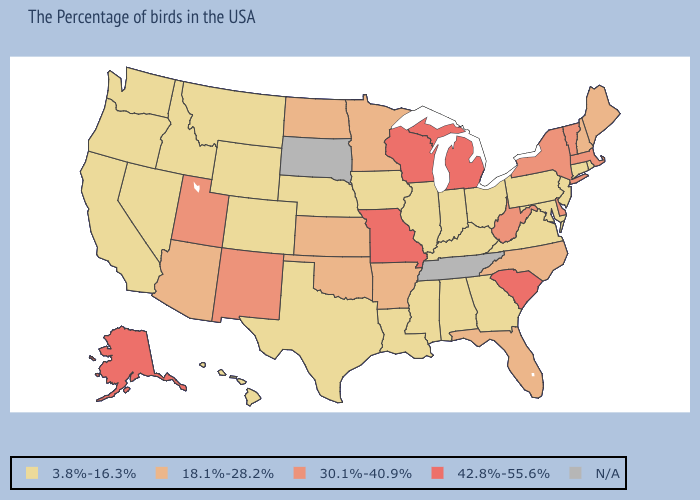What is the highest value in states that border Oregon?
Write a very short answer. 3.8%-16.3%. Name the states that have a value in the range N/A?
Give a very brief answer. Tennessee, South Dakota. Among the states that border Wisconsin , does Michigan have the highest value?
Concise answer only. Yes. Is the legend a continuous bar?
Concise answer only. No. Name the states that have a value in the range 18.1%-28.2%?
Write a very short answer. Maine, New Hampshire, North Carolina, Florida, Arkansas, Minnesota, Kansas, Oklahoma, North Dakota, Arizona. Is the legend a continuous bar?
Give a very brief answer. No. Does Arkansas have the highest value in the USA?
Keep it brief. No. How many symbols are there in the legend?
Be succinct. 5. What is the lowest value in the MidWest?
Concise answer only. 3.8%-16.3%. Does South Carolina have the highest value in the USA?
Give a very brief answer. Yes. Among the states that border Massachusetts , which have the lowest value?
Be succinct. Rhode Island, Connecticut. What is the value of Virginia?
Quick response, please. 3.8%-16.3%. Does Vermont have the highest value in the Northeast?
Be succinct. Yes. Does Massachusetts have the highest value in the Northeast?
Concise answer only. Yes. What is the value of Maryland?
Keep it brief. 3.8%-16.3%. 